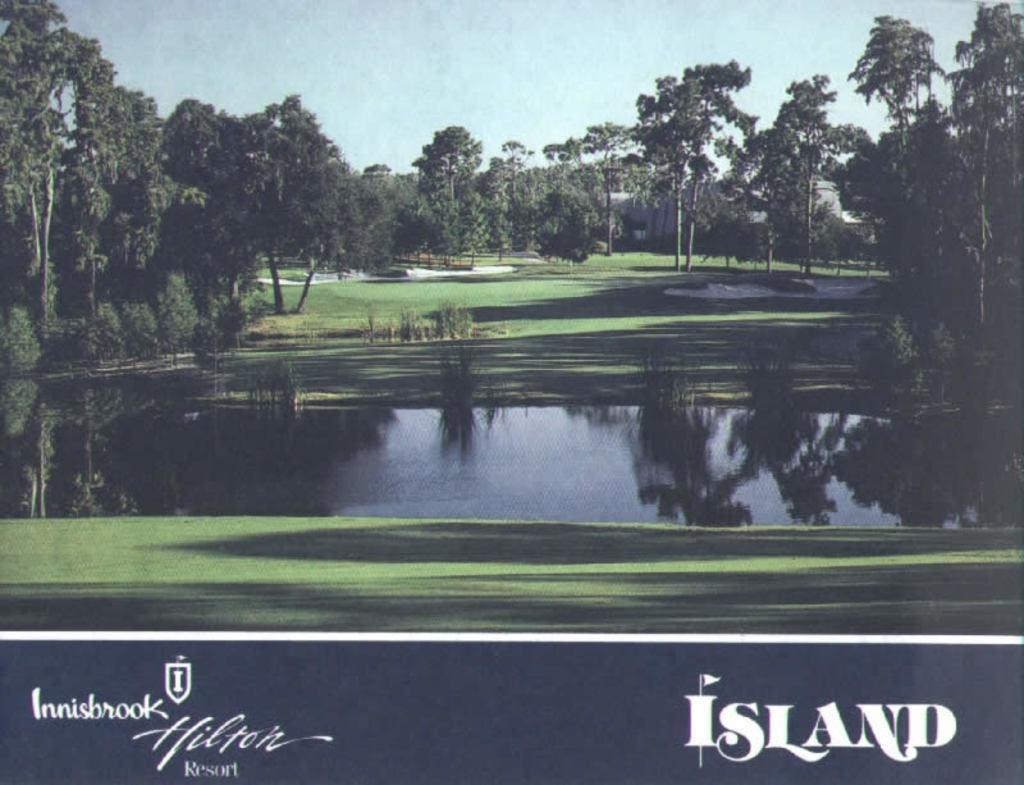Describe this image in one or two sentences. In this image there is a lake, grass, bunkers and trees, at the bottom of the image there is some text. 